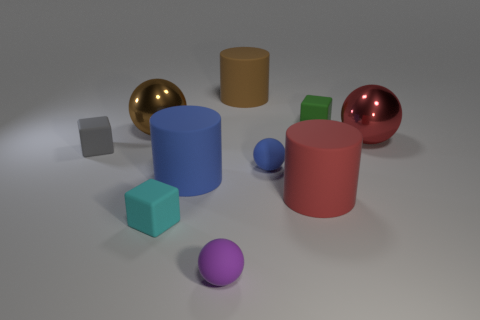There is a cylinder behind the matte block that is to the right of the brown cylinder; is there a small rubber thing right of it?
Provide a short and direct response. Yes. The small thing that is on the left side of the big blue cylinder and behind the blue matte cylinder has what shape?
Give a very brief answer. Cube. What color is the tiny block that is behind the large shiny object that is left of the green matte thing?
Your response must be concise. Green. How big is the metallic ball behind the metal sphere that is in front of the big object that is to the left of the cyan matte thing?
Provide a short and direct response. Large. Does the big brown cylinder have the same material as the ball in front of the blue sphere?
Ensure brevity in your answer.  Yes. There is a red cylinder that is the same material as the small green thing; what is its size?
Provide a short and direct response. Large. Are there any large red metallic objects that have the same shape as the tiny gray thing?
Keep it short and to the point. No. What number of things are red metallic objects behind the small blue matte ball or big rubber cylinders?
Your answer should be very brief. 4. There is a rubber object behind the small green object; does it have the same color as the tiny cube on the right side of the large blue rubber thing?
Your response must be concise. No. What size is the cyan matte thing?
Your answer should be very brief. Small. 